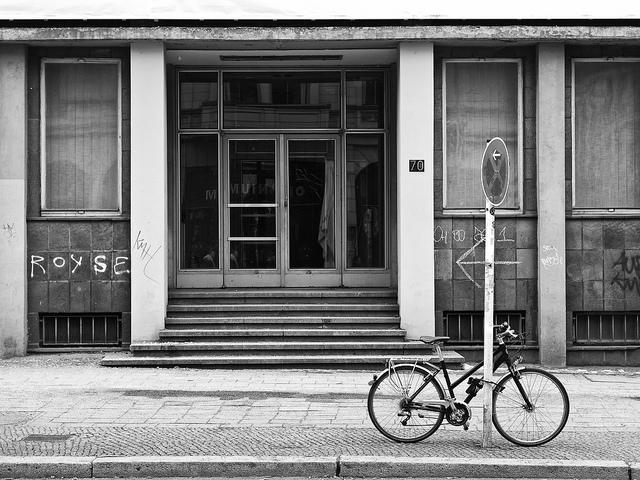How many people in this photo?
Give a very brief answer. 0. How many men are there?
Give a very brief answer. 0. 